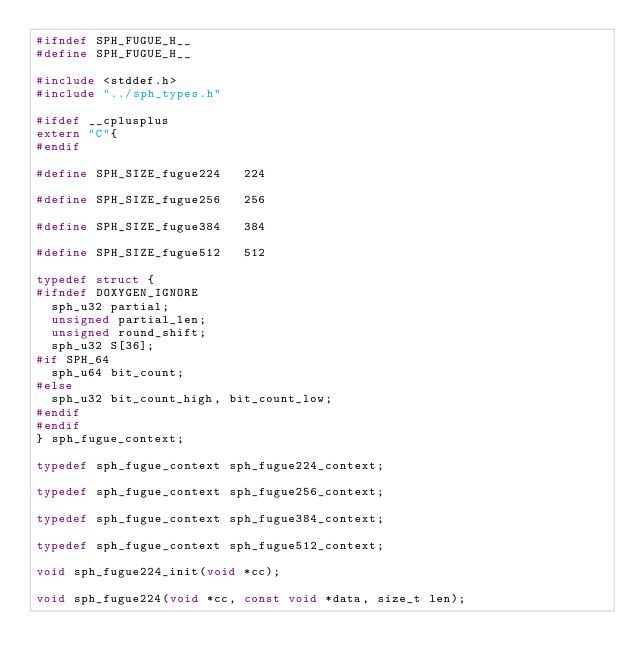Convert code to text. <code><loc_0><loc_0><loc_500><loc_500><_C_>#ifndef SPH_FUGUE_H__
#define SPH_FUGUE_H__

#include <stddef.h>
#include "../sph_types.h"

#ifdef __cplusplus
extern "C"{
#endif

#define SPH_SIZE_fugue224   224

#define SPH_SIZE_fugue256   256

#define SPH_SIZE_fugue384   384

#define SPH_SIZE_fugue512   512

typedef struct {
#ifndef DOXYGEN_IGNORE
	sph_u32 partial;
	unsigned partial_len;
	unsigned round_shift;
	sph_u32 S[36];
#if SPH_64
	sph_u64 bit_count;
#else
	sph_u32 bit_count_high, bit_count_low;
#endif
#endif
} sph_fugue_context;

typedef sph_fugue_context sph_fugue224_context;

typedef sph_fugue_context sph_fugue256_context;

typedef sph_fugue_context sph_fugue384_context;

typedef sph_fugue_context sph_fugue512_context;

void sph_fugue224_init(void *cc);

void sph_fugue224(void *cc, const void *data, size_t len);
</code> 